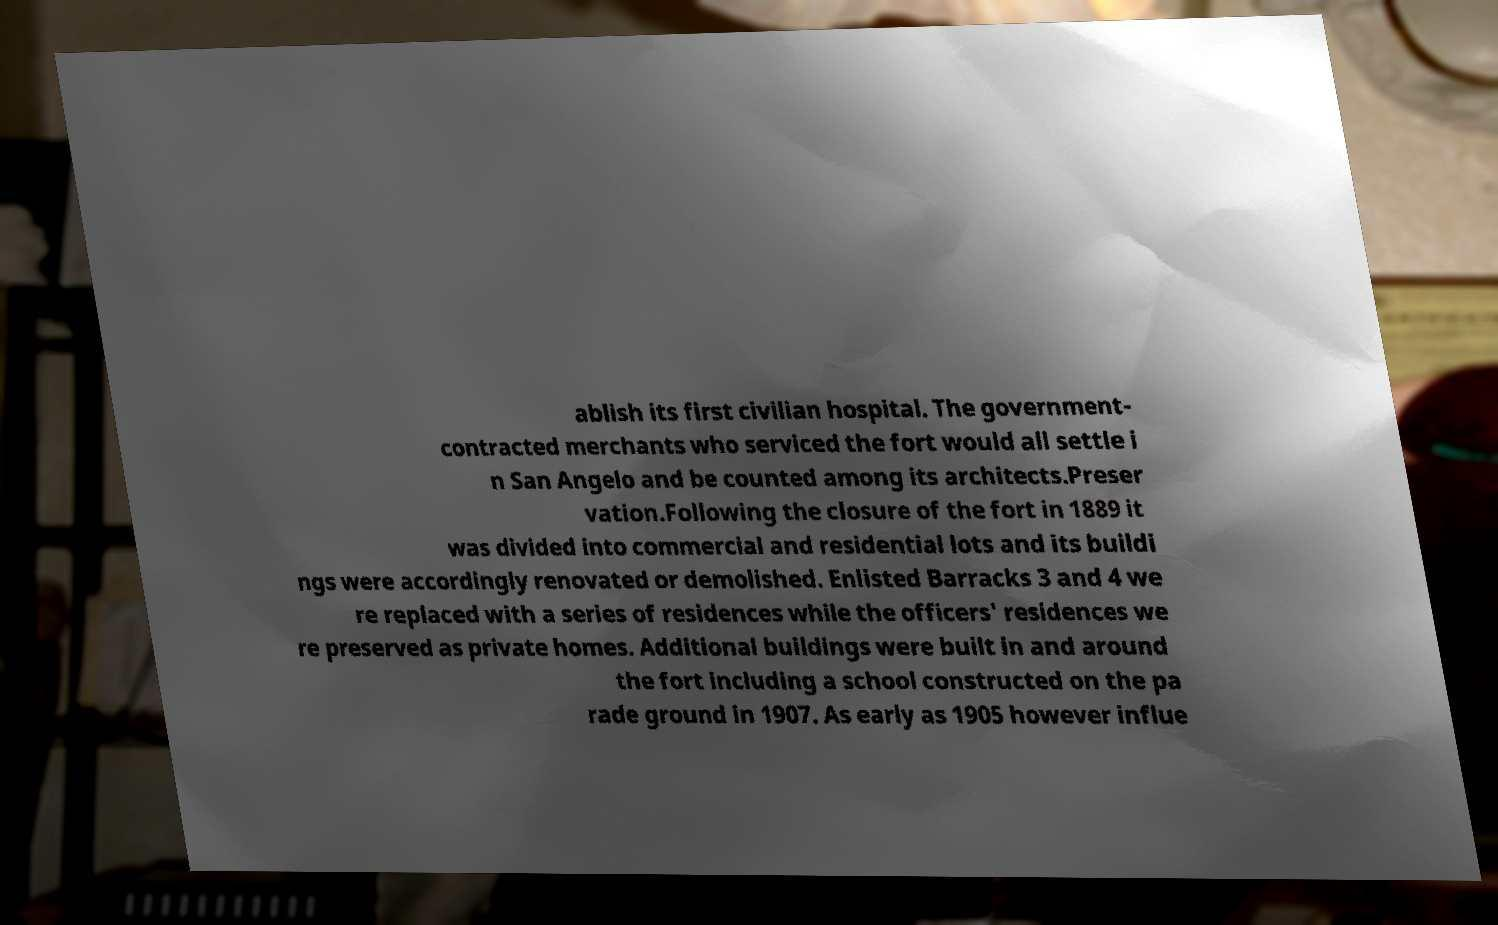Can you read and provide the text displayed in the image?This photo seems to have some interesting text. Can you extract and type it out for me? ablish its first civilian hospital. The government- contracted merchants who serviced the fort would all settle i n San Angelo and be counted among its architects.Preser vation.Following the closure of the fort in 1889 it was divided into commercial and residential lots and its buildi ngs were accordingly renovated or demolished. Enlisted Barracks 3 and 4 we re replaced with a series of residences while the officers' residences we re preserved as private homes. Additional buildings were built in and around the fort including a school constructed on the pa rade ground in 1907. As early as 1905 however influe 